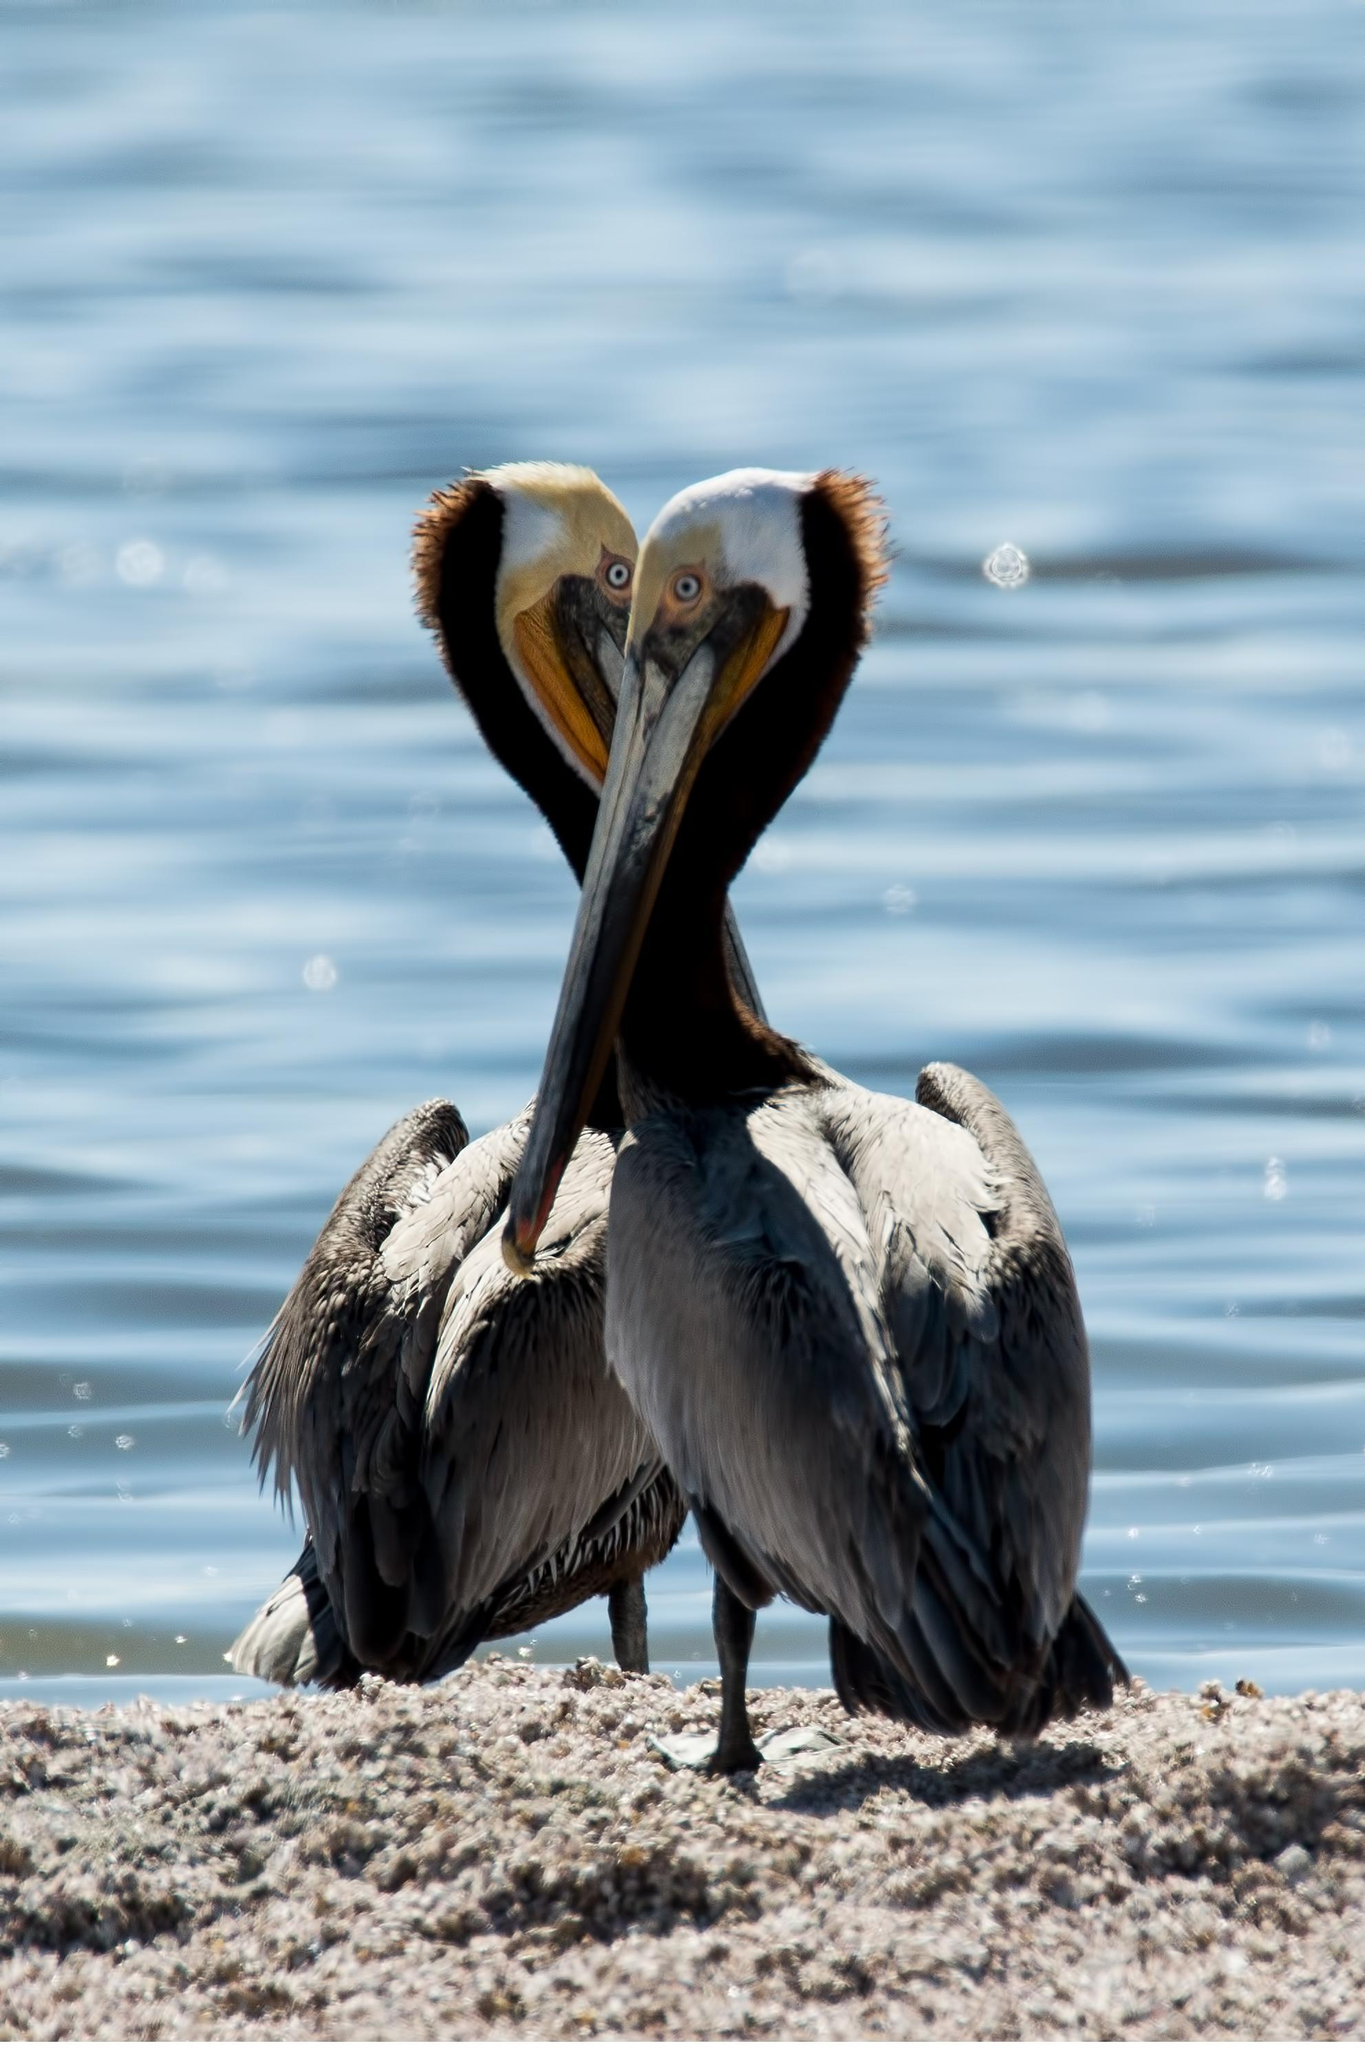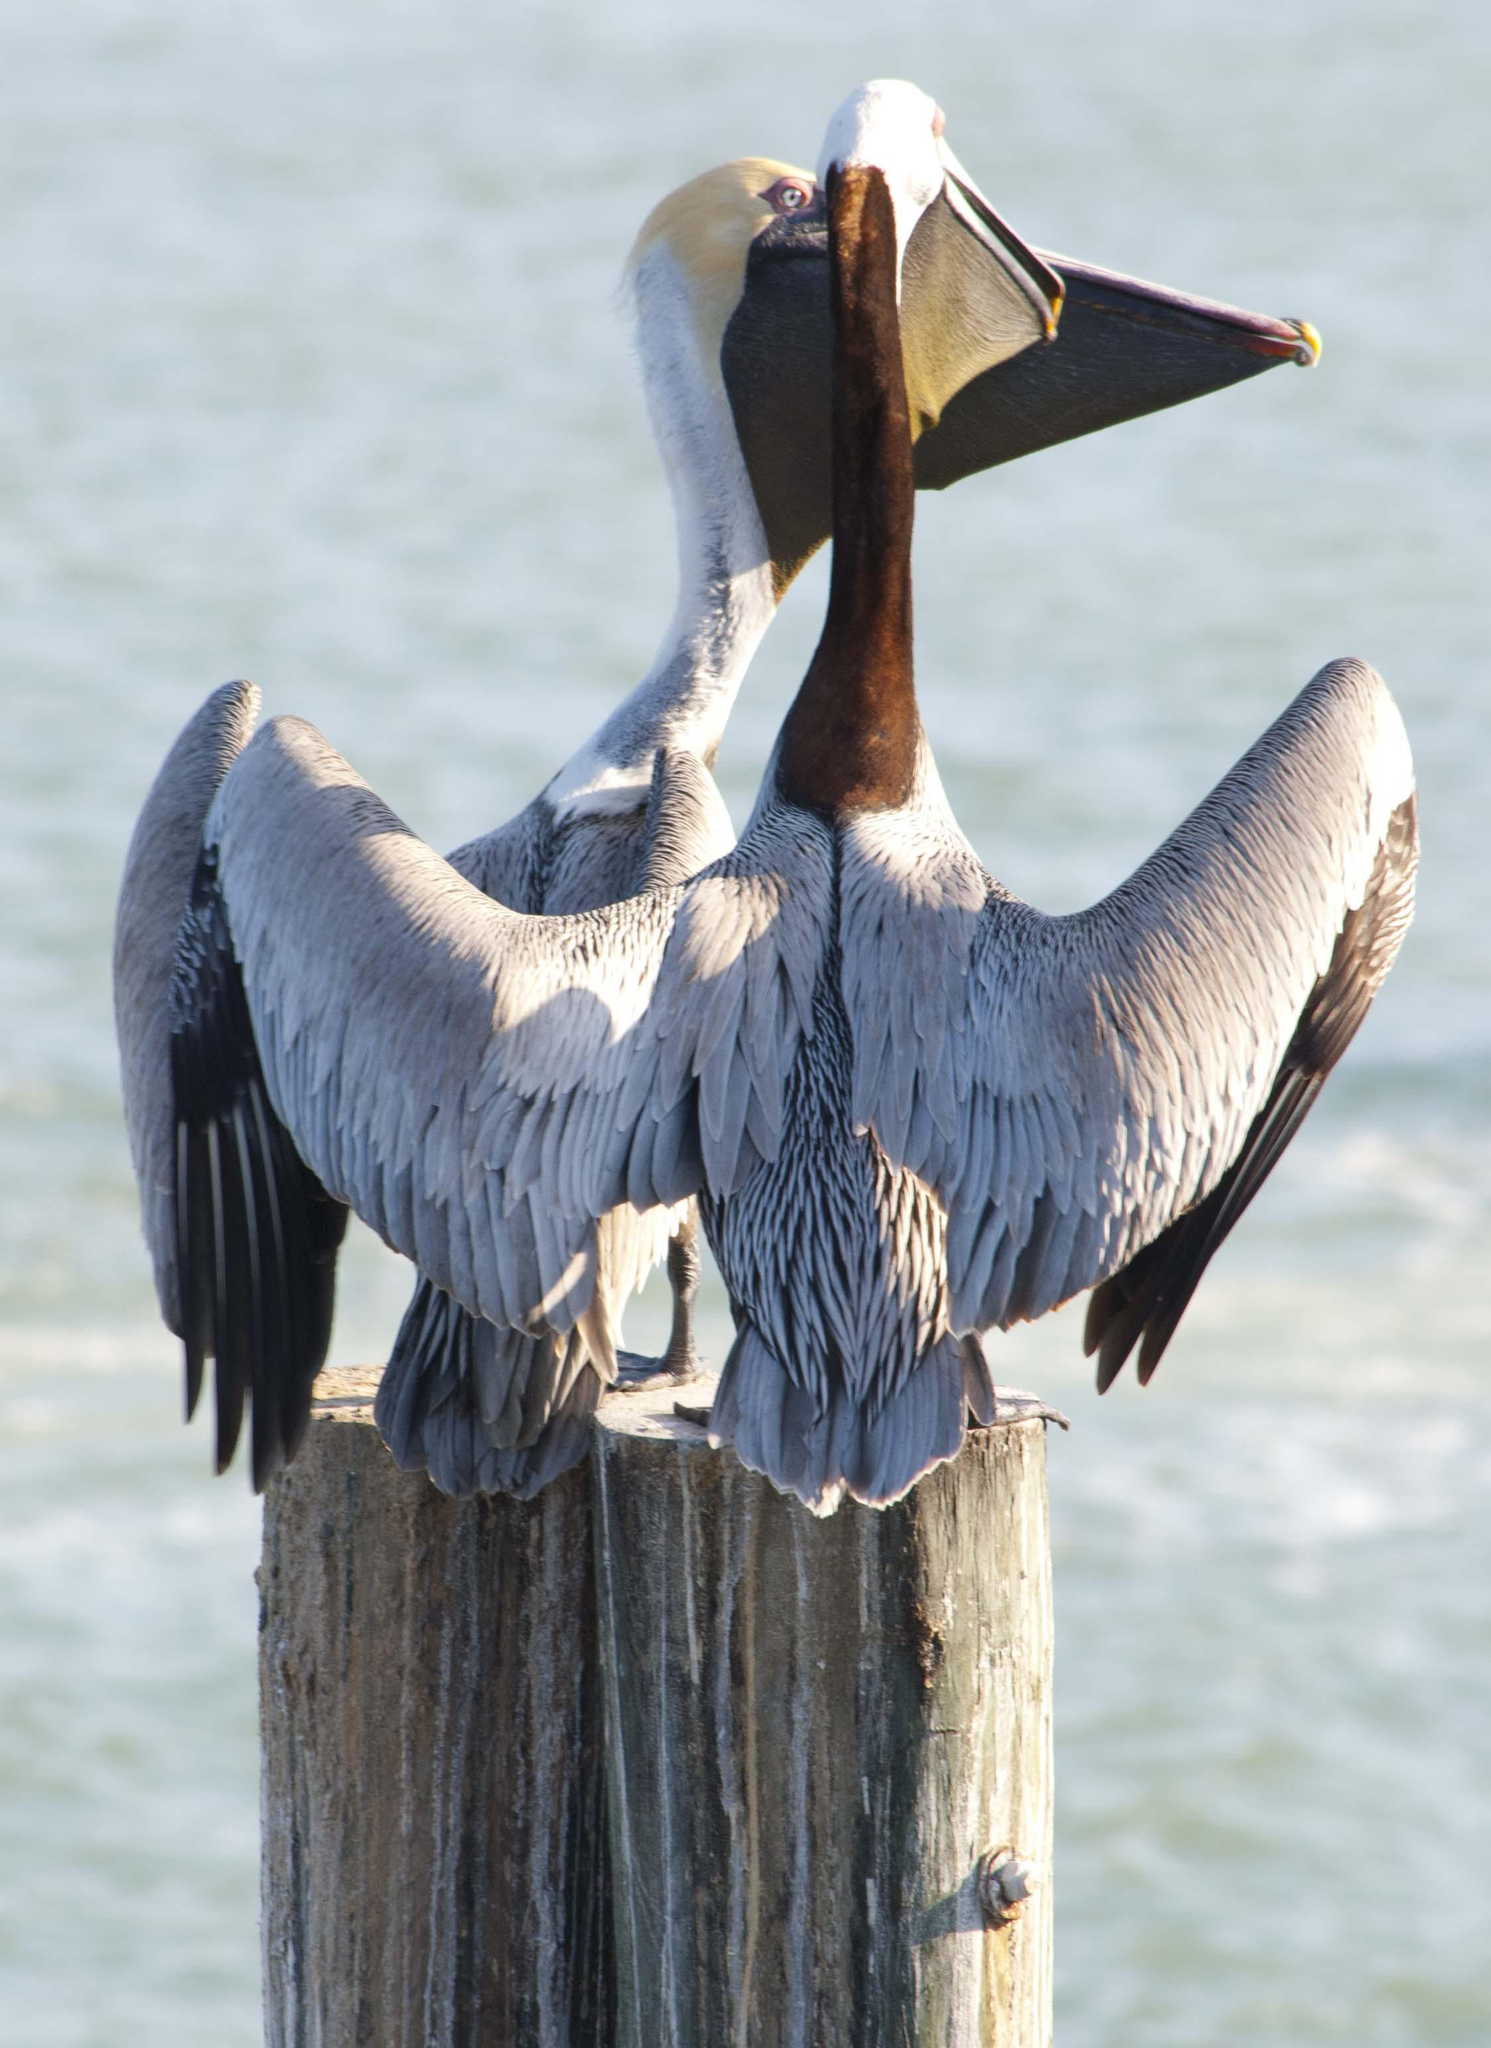The first image is the image on the left, the second image is the image on the right. Considering the images on both sides, is "An image shows only two birds, which are overlapped facing each other so their heads and necks form a heart shape." valid? Answer yes or no. Yes. The first image is the image on the left, the second image is the image on the right. Analyze the images presented: Is the assertion "Two birds are perched on a post in one of the images." valid? Answer yes or no. Yes. 